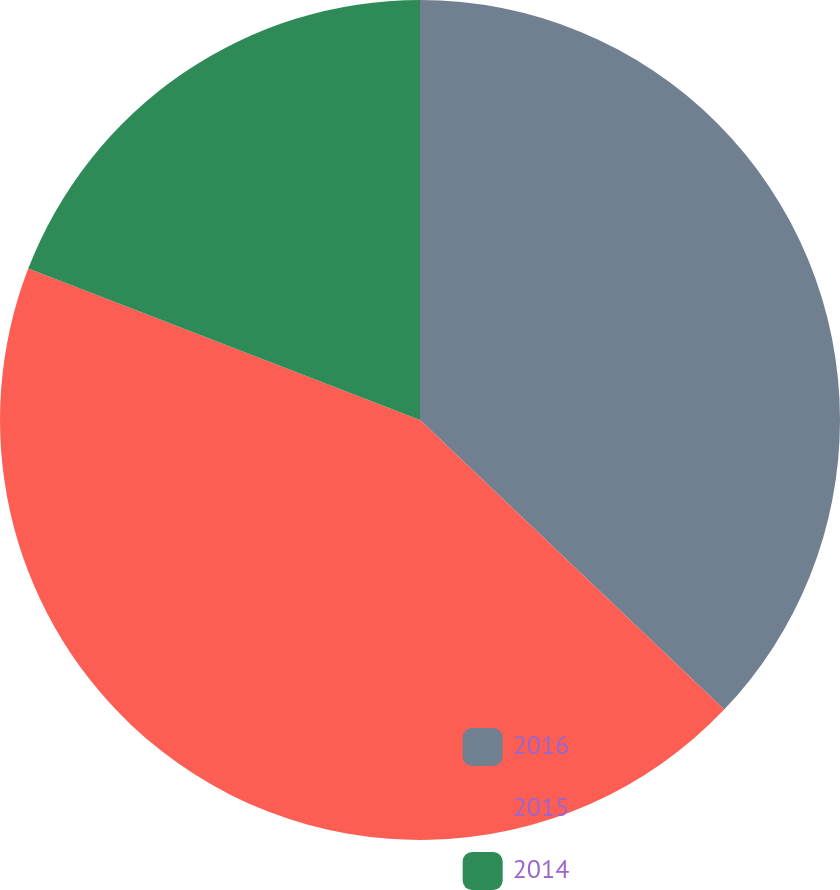<chart> <loc_0><loc_0><loc_500><loc_500><pie_chart><fcel>2016<fcel>2015<fcel>2014<nl><fcel>37.11%<fcel>43.76%<fcel>19.13%<nl></chart> 